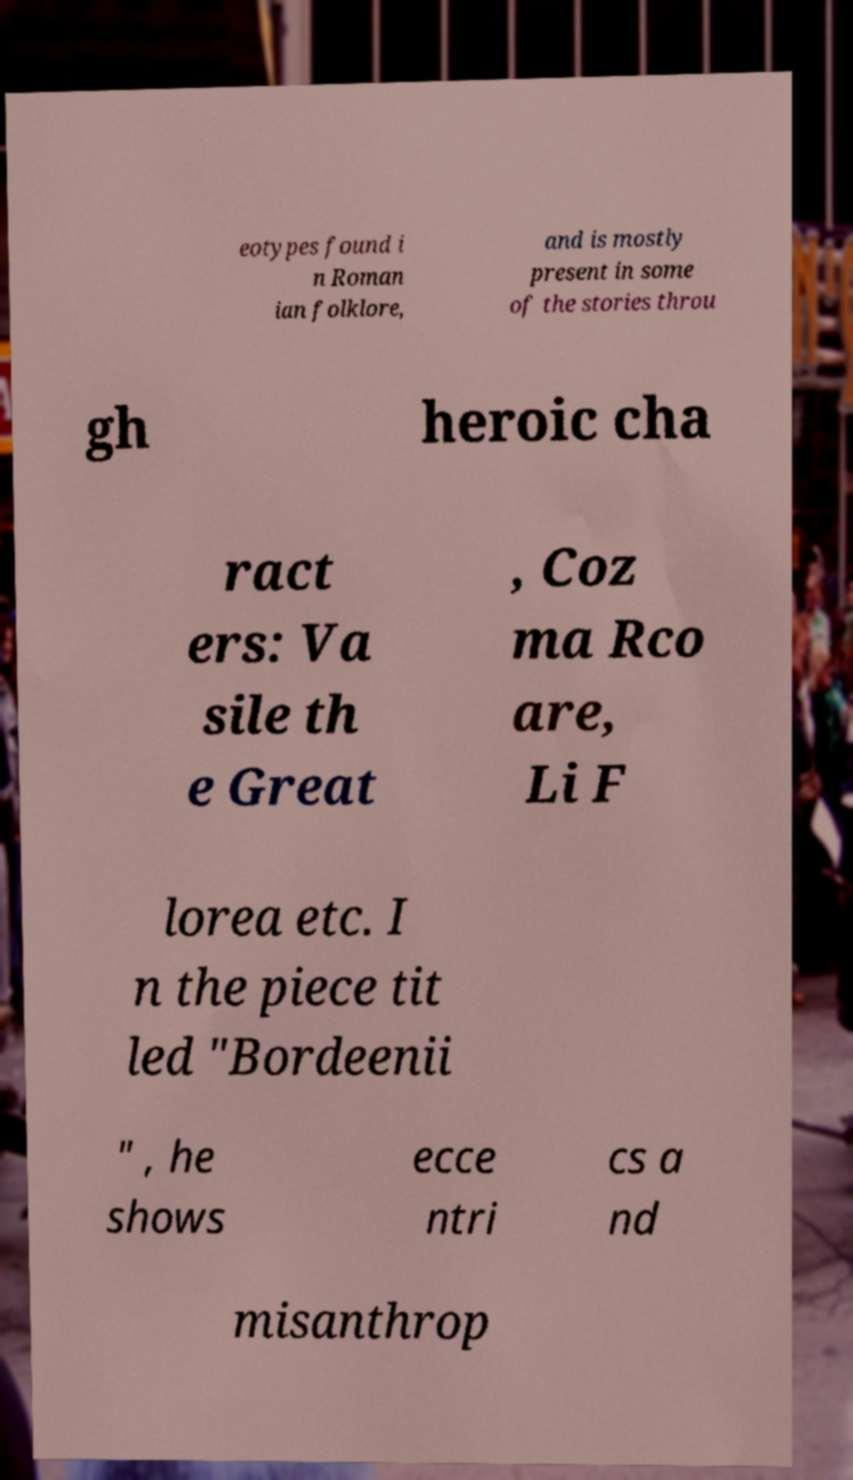There's text embedded in this image that I need extracted. Can you transcribe it verbatim? eotypes found i n Roman ian folklore, and is mostly present in some of the stories throu gh heroic cha ract ers: Va sile th e Great , Coz ma Rco are, Li F lorea etc. I n the piece tit led "Bordeenii " , he shows ecce ntri cs a nd misanthrop 